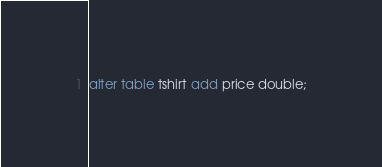<code> <loc_0><loc_0><loc_500><loc_500><_SQL_>alter table tshirt add price double;</code> 